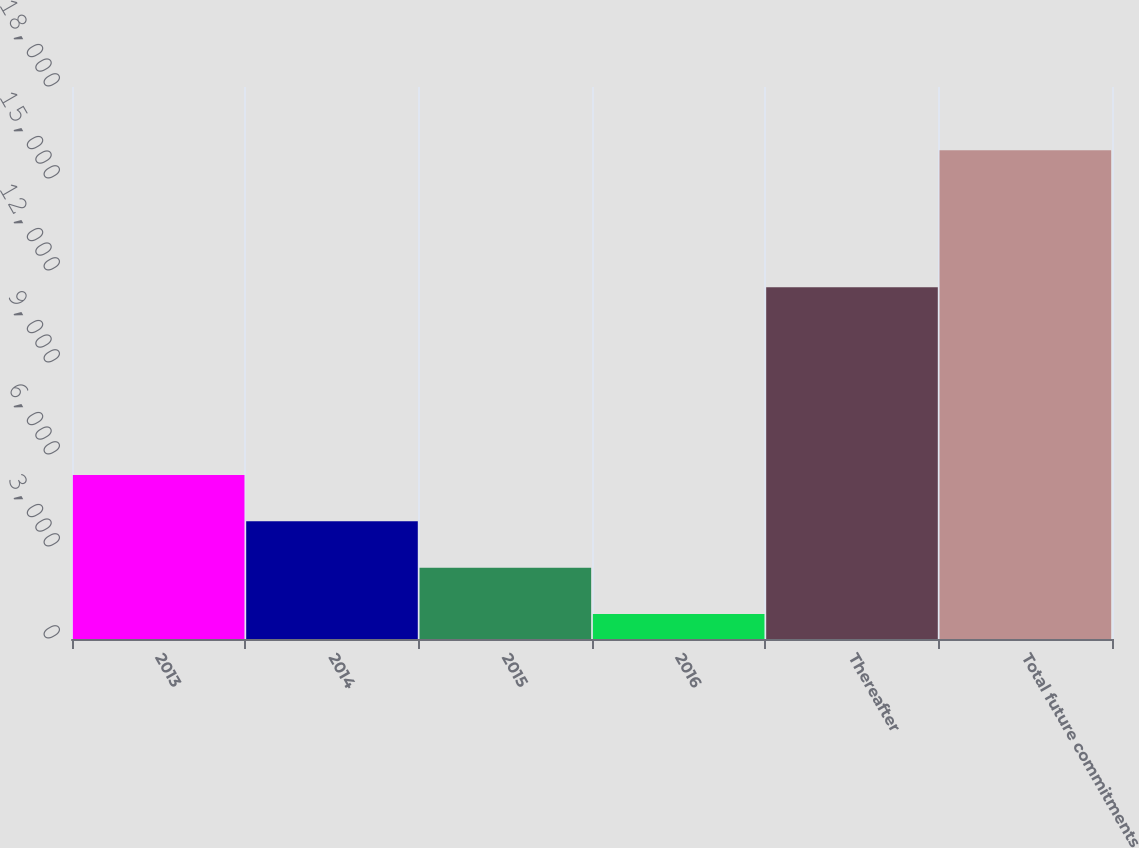Convert chart. <chart><loc_0><loc_0><loc_500><loc_500><bar_chart><fcel>2013<fcel>2014<fcel>2015<fcel>2016<fcel>Thereafter<fcel>Total future commitments<nl><fcel>5350.7<fcel>3838.8<fcel>2326.9<fcel>815<fcel>11468<fcel>15934<nl></chart> 